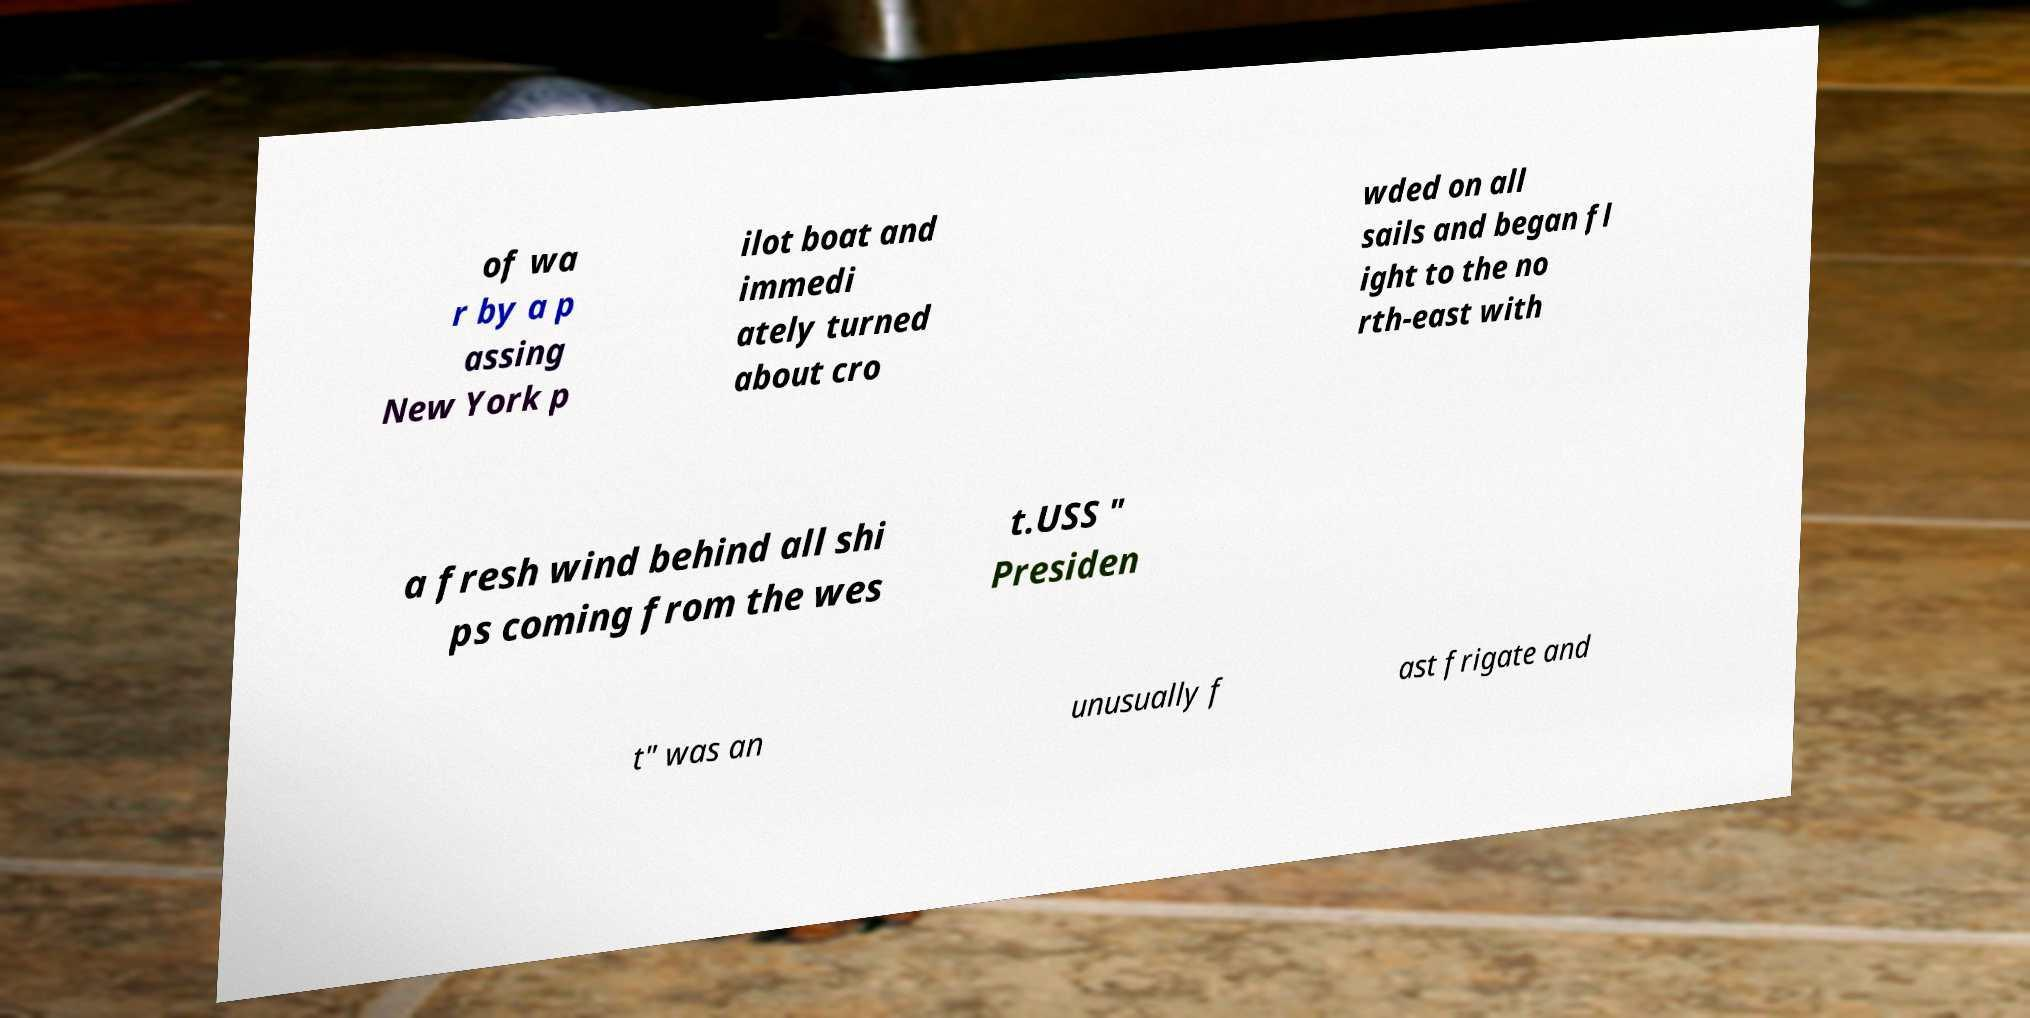For documentation purposes, I need the text within this image transcribed. Could you provide that? of wa r by a p assing New York p ilot boat and immedi ately turned about cro wded on all sails and began fl ight to the no rth-east with a fresh wind behind all shi ps coming from the wes t.USS " Presiden t" was an unusually f ast frigate and 